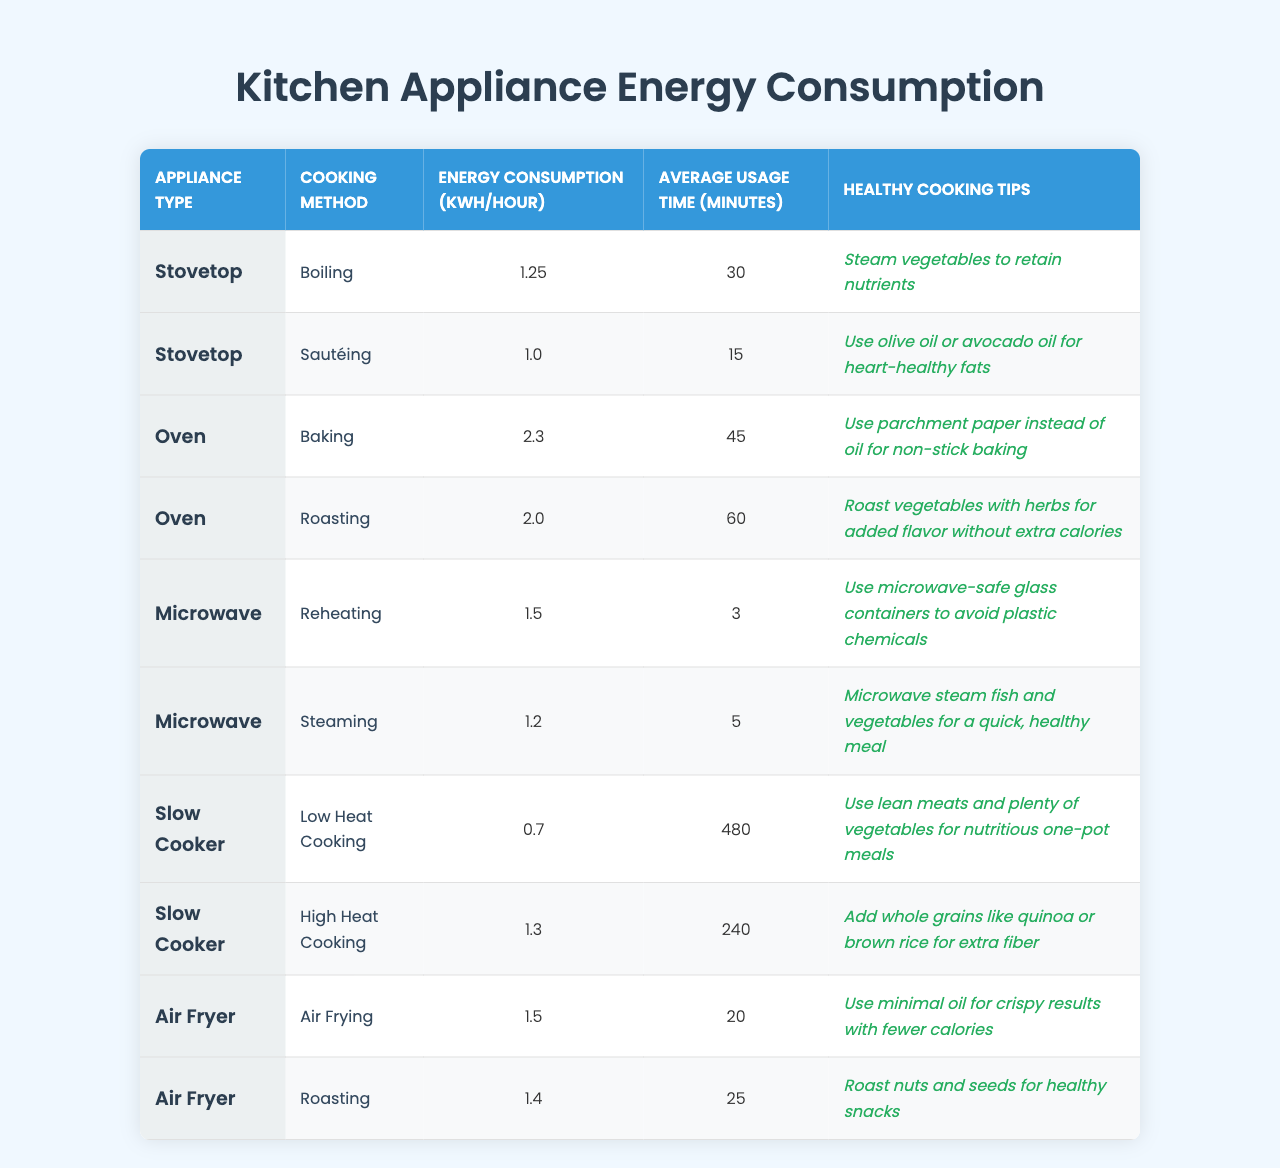What is the energy consumption for boiling on a stovetop? The table shows that the energy consumption for boiling on a stovetop is 1.25 kWh/hour.
Answer: 1.25 kWh/hour What cooking method consumes the least energy? When comparing energy consumption, low heat cooking in a slow cooker uses only 0.7 kWh/hour, making it the least energy-consuming method.
Answer: Low heat cooking How long does it take to sauté on a stovetop? The table indicates that sautéing on a stovetop takes 15 minutes.
Answer: 15 minutes Which appliance requires the most energy for roasting? The oven uses 2.0 kWh/hour for roasting, while the air fryer uses 1.4 kWh/hour; therefore, the oven requires more energy.
Answer: Oven What is the average energy consumption for the microwave cooking methods? The microwave has two cooking methods: reheating at 1.5 kWh/hour and steaming at 1.2 kWh/hour. The average is (1.5 + 1.2) / 2 = 1.35 kWh/hour.
Answer: 1.35 kWh/hour How many minutes does it take for high heat cooking in a slow cooker? High heat cooking in a slow cooker takes 240 minutes according to the table.
Answer: 240 minutes Is it true that air frying uses less energy than baking? Yes, air frying uses 1.5 kWh/hour while baking uses 2.3 kWh/hour, so air frying consumes less energy.
Answer: Yes Calculate the total average cooking time for using the stovetop methods. For stovetop methods, boiling takes 30 minutes and sautéing takes 15 minutes. Total time is 30 + 15 = 45 minutes, and since there are two methods, the average is 45 / 2 = 22.5 minutes.
Answer: 22.5 minutes Which healthy cooking tip is associated with reheating in the microwave? The healthy cooking tip for reheating in the microwave is to use microwave-safe glass containers to avoid plastic chemicals.
Answer: Use glass containers What is the sum of energy consumption for all cooking methods using the oven? The oven has baking at 2.3 kWh/hour and roasting at 2.0 kWh/hour. The sum is 2.3 + 2.0 = 4.3 kWh/hour.
Answer: 4.3 kWh/hour 